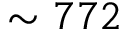Convert formula to latex. <formula><loc_0><loc_0><loc_500><loc_500>\sim 7 7 2</formula> 